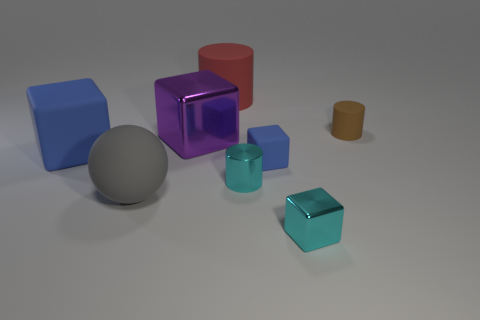How many objects are there, and can you describe their shapes? There are a total of six objects in the image. Starting from the left, there's a large blue cube, a sphere that seems metallic, a purple transparent cube, a red cylinder, a small blue cube, and a small yellow cylinder. 